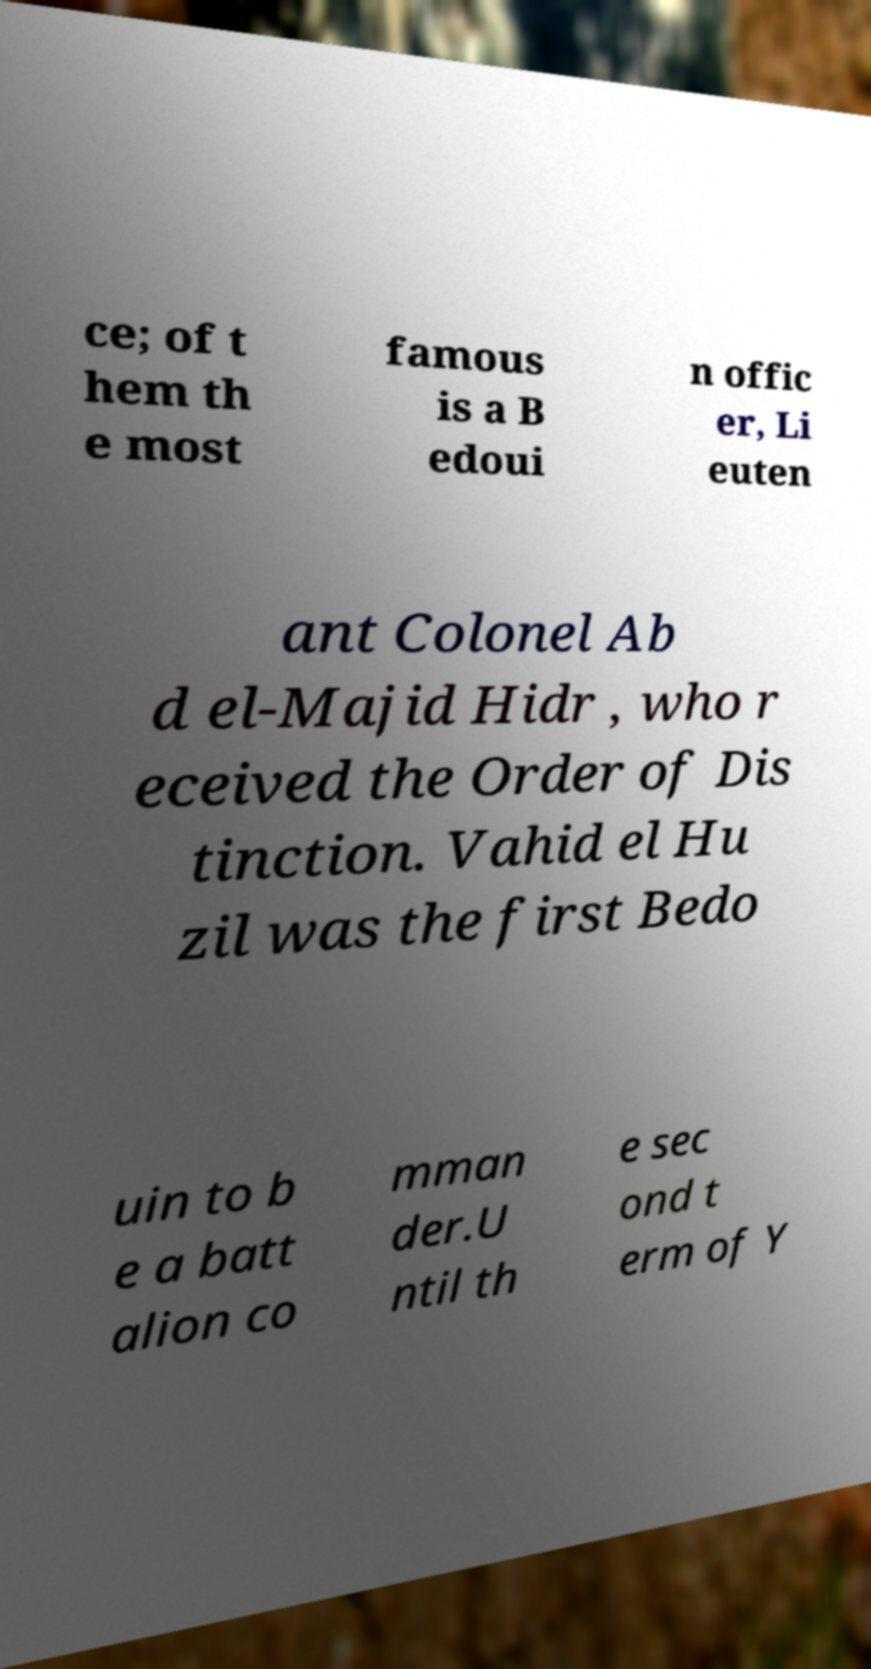What messages or text are displayed in this image? I need them in a readable, typed format. ce; of t hem th e most famous is a B edoui n offic er, Li euten ant Colonel Ab d el-Majid Hidr , who r eceived the Order of Dis tinction. Vahid el Hu zil was the first Bedo uin to b e a batt alion co mman der.U ntil th e sec ond t erm of Y 